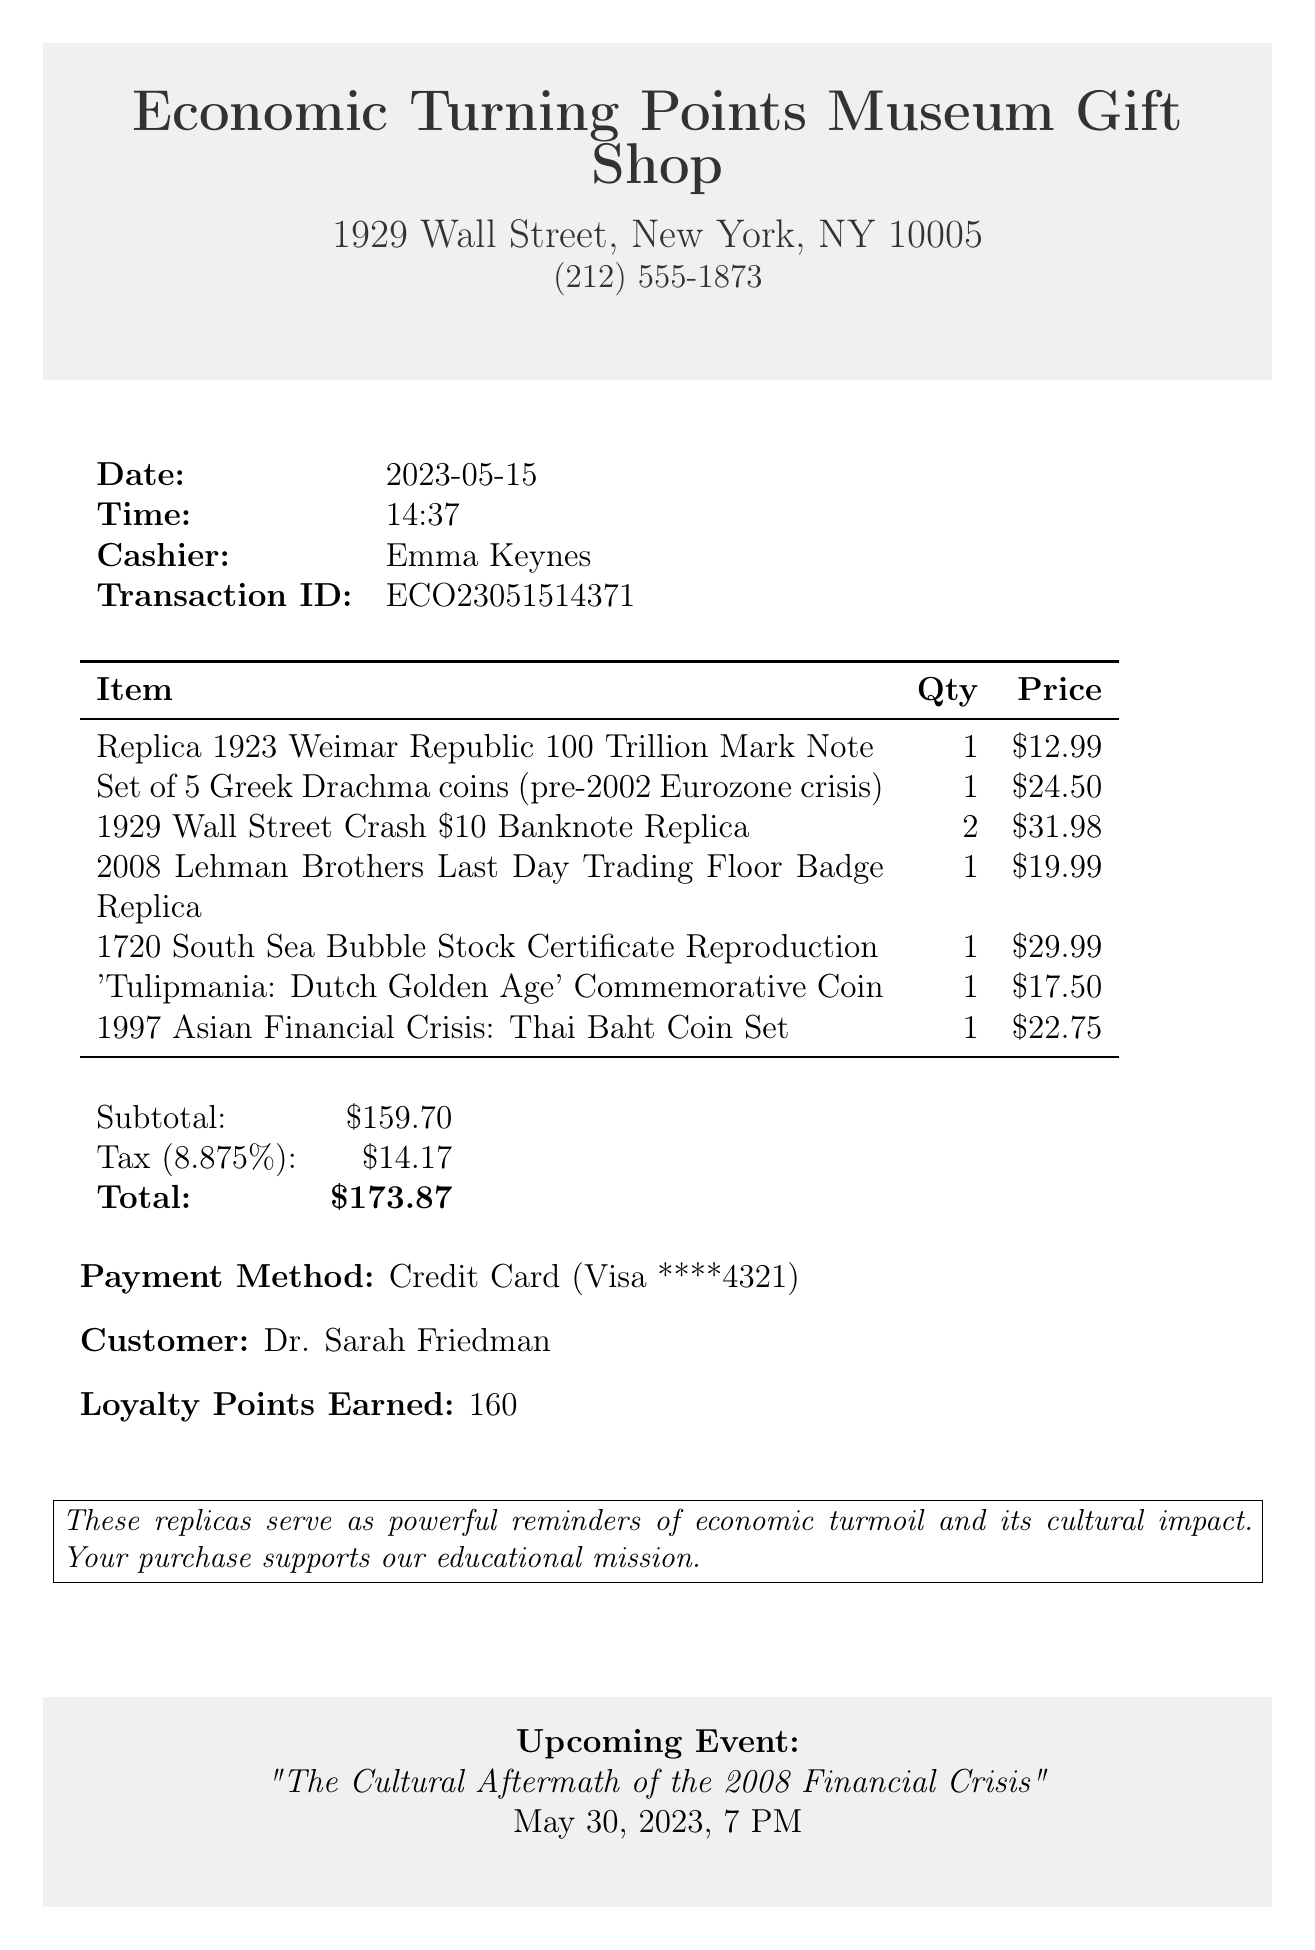What is the store name? The store name is listed at the top of the receipt.
Answer: Economic Turning Points Museum Gift Shop Who is the cashier? The cashier's name is provided in the transaction details.
Answer: Emma Keynes What is the date of the transaction? The date appears prominently in the transaction details section.
Answer: 2023-05-15 How many items were purchased in total? The number of items is reflected in the quantity column of the items list.
Answer: 7 What is the total amount spent? The total amount is indicated in the summary section of the receipt.
Answer: $173.87 What is the subtotal before tax? The subtotal is given just before the tax calculation.
Answer: $159.70 What is the payment method used? The payment method can be found in the payment information section.
Answer: Credit Card What loyalty points were earned from this purchase? The loyalty points are noted near the bottom of the receipt.
Answer: 160 What upcoming event is mentioned? The upcoming event is listed in the footer section with details.
Answer: "The Cultural Aftermath of the 2008 Financial Crisis" 